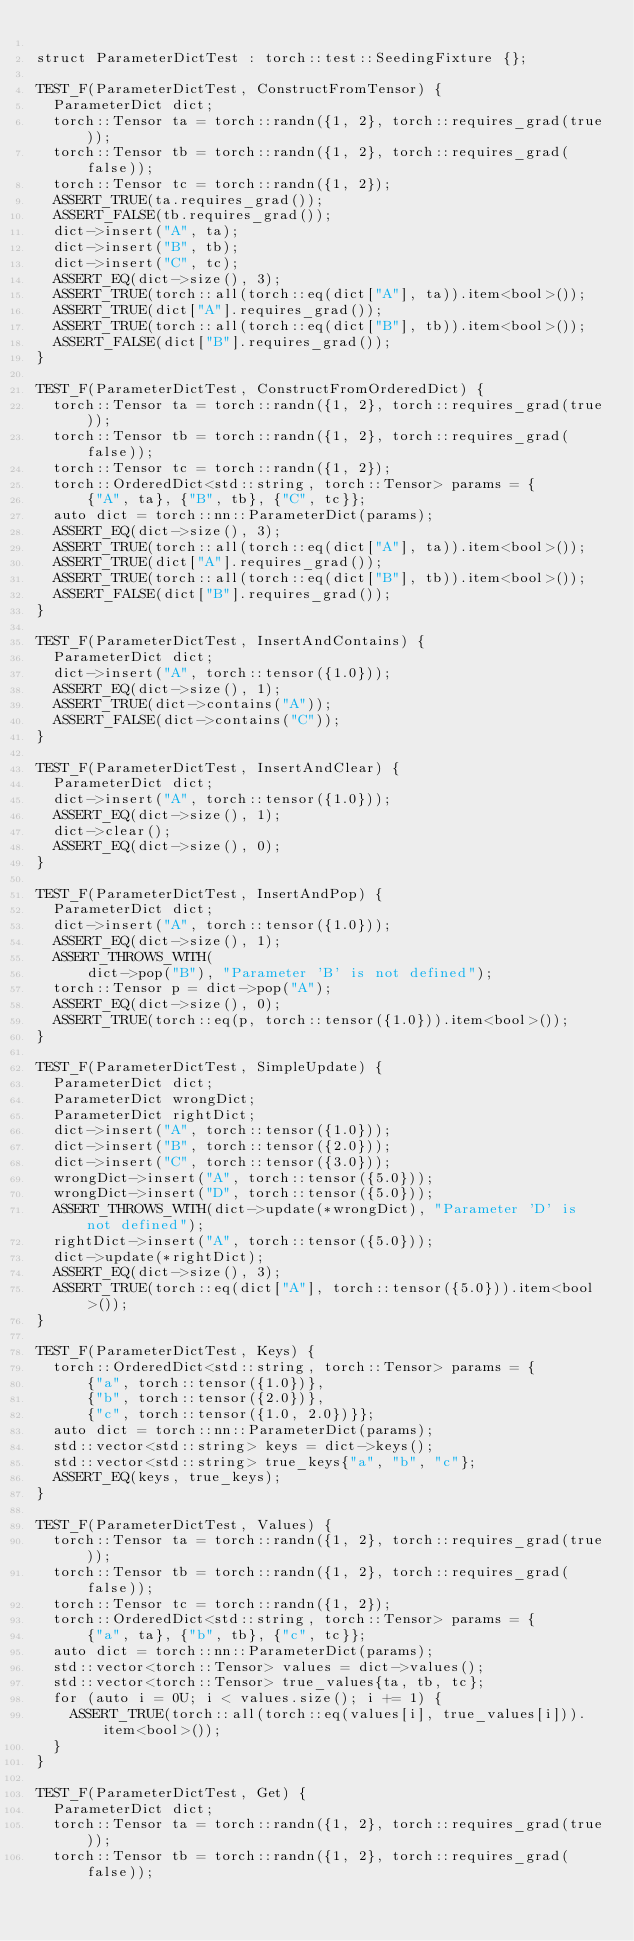Convert code to text. <code><loc_0><loc_0><loc_500><loc_500><_C++_>
struct ParameterDictTest : torch::test::SeedingFixture {};

TEST_F(ParameterDictTest, ConstructFromTensor) {
  ParameterDict dict;
  torch::Tensor ta = torch::randn({1, 2}, torch::requires_grad(true));
  torch::Tensor tb = torch::randn({1, 2}, torch::requires_grad(false));
  torch::Tensor tc = torch::randn({1, 2});
  ASSERT_TRUE(ta.requires_grad());
  ASSERT_FALSE(tb.requires_grad());
  dict->insert("A", ta);
  dict->insert("B", tb);
  dict->insert("C", tc);
  ASSERT_EQ(dict->size(), 3);
  ASSERT_TRUE(torch::all(torch::eq(dict["A"], ta)).item<bool>());
  ASSERT_TRUE(dict["A"].requires_grad());
  ASSERT_TRUE(torch::all(torch::eq(dict["B"], tb)).item<bool>());
  ASSERT_FALSE(dict["B"].requires_grad());
}

TEST_F(ParameterDictTest, ConstructFromOrderedDict) {
  torch::Tensor ta = torch::randn({1, 2}, torch::requires_grad(true));
  torch::Tensor tb = torch::randn({1, 2}, torch::requires_grad(false));
  torch::Tensor tc = torch::randn({1, 2});
  torch::OrderedDict<std::string, torch::Tensor> params = {
      {"A", ta}, {"B", tb}, {"C", tc}};
  auto dict = torch::nn::ParameterDict(params);
  ASSERT_EQ(dict->size(), 3);
  ASSERT_TRUE(torch::all(torch::eq(dict["A"], ta)).item<bool>());
  ASSERT_TRUE(dict["A"].requires_grad());
  ASSERT_TRUE(torch::all(torch::eq(dict["B"], tb)).item<bool>());
  ASSERT_FALSE(dict["B"].requires_grad());
}

TEST_F(ParameterDictTest, InsertAndContains) {
  ParameterDict dict;
  dict->insert("A", torch::tensor({1.0}));
  ASSERT_EQ(dict->size(), 1);
  ASSERT_TRUE(dict->contains("A"));
  ASSERT_FALSE(dict->contains("C"));
}

TEST_F(ParameterDictTest, InsertAndClear) {
  ParameterDict dict;
  dict->insert("A", torch::tensor({1.0}));
  ASSERT_EQ(dict->size(), 1);
  dict->clear();
  ASSERT_EQ(dict->size(), 0);
}

TEST_F(ParameterDictTest, InsertAndPop) {
  ParameterDict dict;
  dict->insert("A", torch::tensor({1.0}));
  ASSERT_EQ(dict->size(), 1);
  ASSERT_THROWS_WITH(
      dict->pop("B"), "Parameter 'B' is not defined");
  torch::Tensor p = dict->pop("A");
  ASSERT_EQ(dict->size(), 0);
  ASSERT_TRUE(torch::eq(p, torch::tensor({1.0})).item<bool>());
}

TEST_F(ParameterDictTest, SimpleUpdate) {
  ParameterDict dict;
  ParameterDict wrongDict;
  ParameterDict rightDict;
  dict->insert("A", torch::tensor({1.0}));
  dict->insert("B", torch::tensor({2.0}));
  dict->insert("C", torch::tensor({3.0}));
  wrongDict->insert("A", torch::tensor({5.0}));
  wrongDict->insert("D", torch::tensor({5.0}));
  ASSERT_THROWS_WITH(dict->update(*wrongDict), "Parameter 'D' is not defined");
  rightDict->insert("A", torch::tensor({5.0}));
  dict->update(*rightDict);
  ASSERT_EQ(dict->size(), 3);
  ASSERT_TRUE(torch::eq(dict["A"], torch::tensor({5.0})).item<bool>());
}

TEST_F(ParameterDictTest, Keys) {
  torch::OrderedDict<std::string, torch::Tensor> params = {
      {"a", torch::tensor({1.0})},
      {"b", torch::tensor({2.0})},
      {"c", torch::tensor({1.0, 2.0})}};
  auto dict = torch::nn::ParameterDict(params);
  std::vector<std::string> keys = dict->keys();
  std::vector<std::string> true_keys{"a", "b", "c"};
  ASSERT_EQ(keys, true_keys);
}

TEST_F(ParameterDictTest, Values) {
  torch::Tensor ta = torch::randn({1, 2}, torch::requires_grad(true));
  torch::Tensor tb = torch::randn({1, 2}, torch::requires_grad(false));
  torch::Tensor tc = torch::randn({1, 2});
  torch::OrderedDict<std::string, torch::Tensor> params = {
      {"a", ta}, {"b", tb}, {"c", tc}};
  auto dict = torch::nn::ParameterDict(params);
  std::vector<torch::Tensor> values = dict->values();
  std::vector<torch::Tensor> true_values{ta, tb, tc};
  for (auto i = 0U; i < values.size(); i += 1) {
    ASSERT_TRUE(torch::all(torch::eq(values[i], true_values[i])).item<bool>());
  }
}

TEST_F(ParameterDictTest, Get) {
  ParameterDict dict;
  torch::Tensor ta = torch::randn({1, 2}, torch::requires_grad(true));
  torch::Tensor tb = torch::randn({1, 2}, torch::requires_grad(false));</code> 